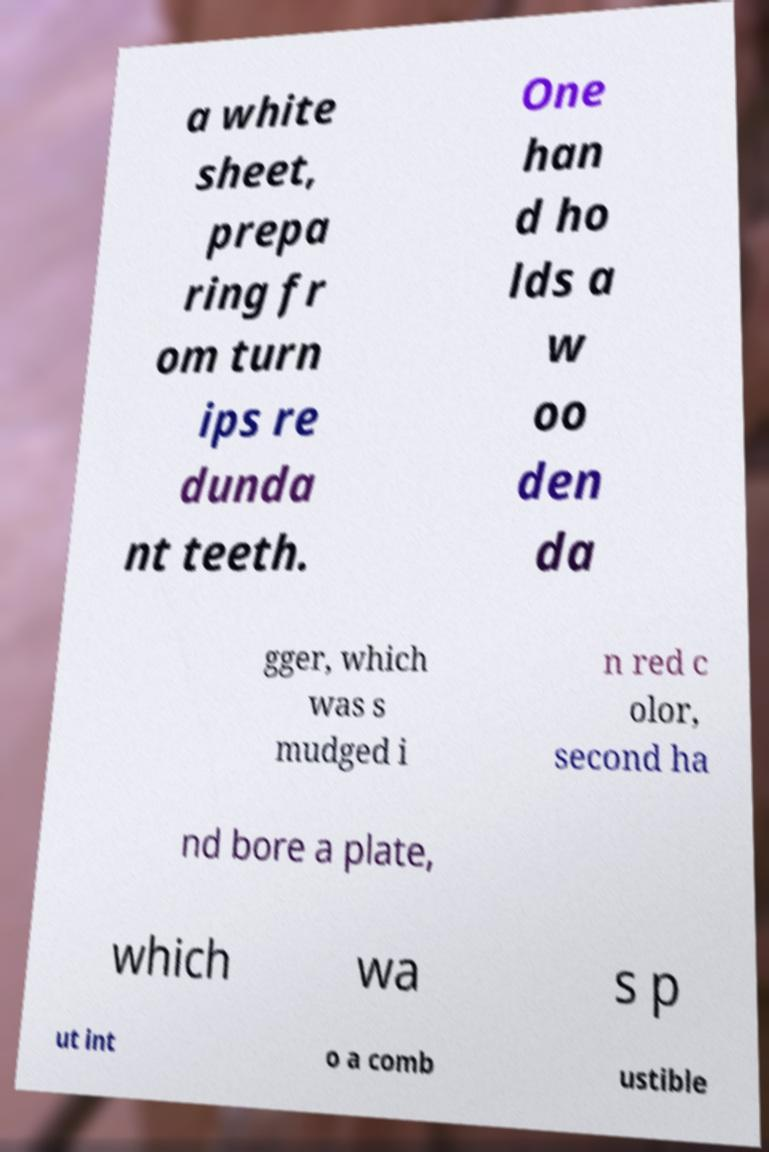For documentation purposes, I need the text within this image transcribed. Could you provide that? a white sheet, prepa ring fr om turn ips re dunda nt teeth. One han d ho lds a w oo den da gger, which was s mudged i n red c olor, second ha nd bore a plate, which wa s p ut int o a comb ustible 